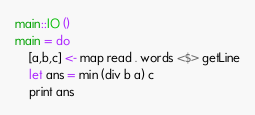<code> <loc_0><loc_0><loc_500><loc_500><_Haskell_>main::IO ()
main = do
    [a,b,c] <- map read . words <$> getLine
    let ans = min (div b a) c
    print ans</code> 